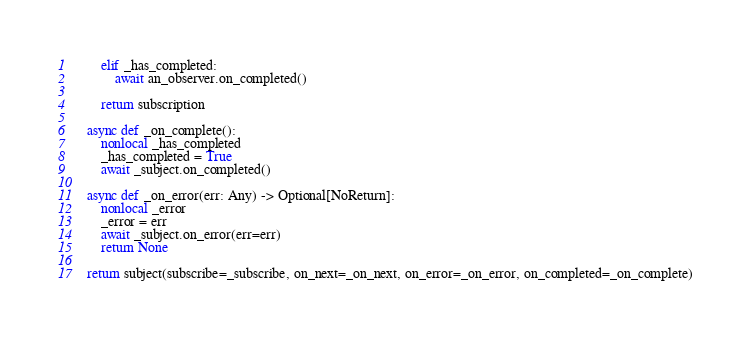Convert code to text. <code><loc_0><loc_0><loc_500><loc_500><_Python_>        elif _has_completed:
            await an_observer.on_completed()

        return subscription

    async def _on_complete():
        nonlocal _has_completed
        _has_completed = True
        await _subject.on_completed()

    async def _on_error(err: Any) -> Optional[NoReturn]:
        nonlocal _error
        _error = err
        await _subject.on_error(err=err)
        return None

    return subject(subscribe=_subscribe, on_next=_on_next, on_error=_on_error, on_completed=_on_complete)
</code> 